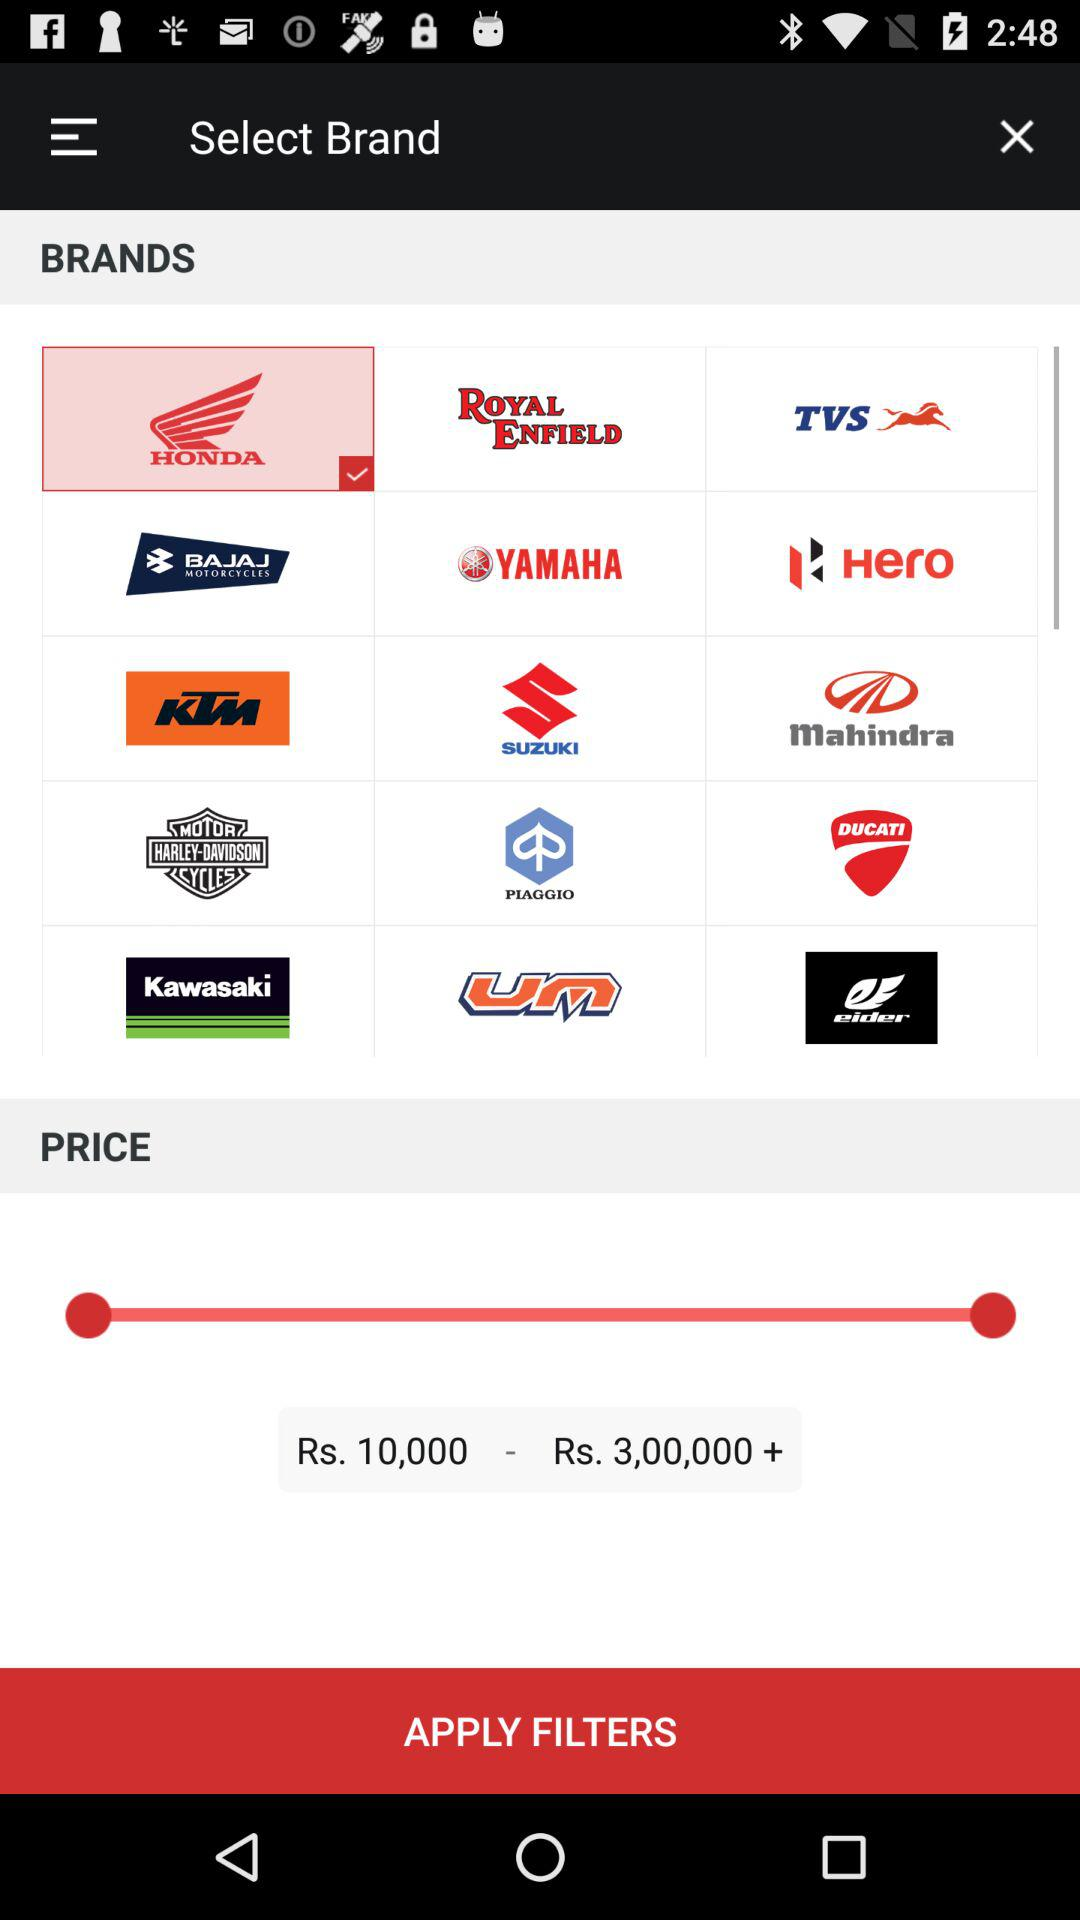Which brand is selected? The selected brand is "HONDA". 